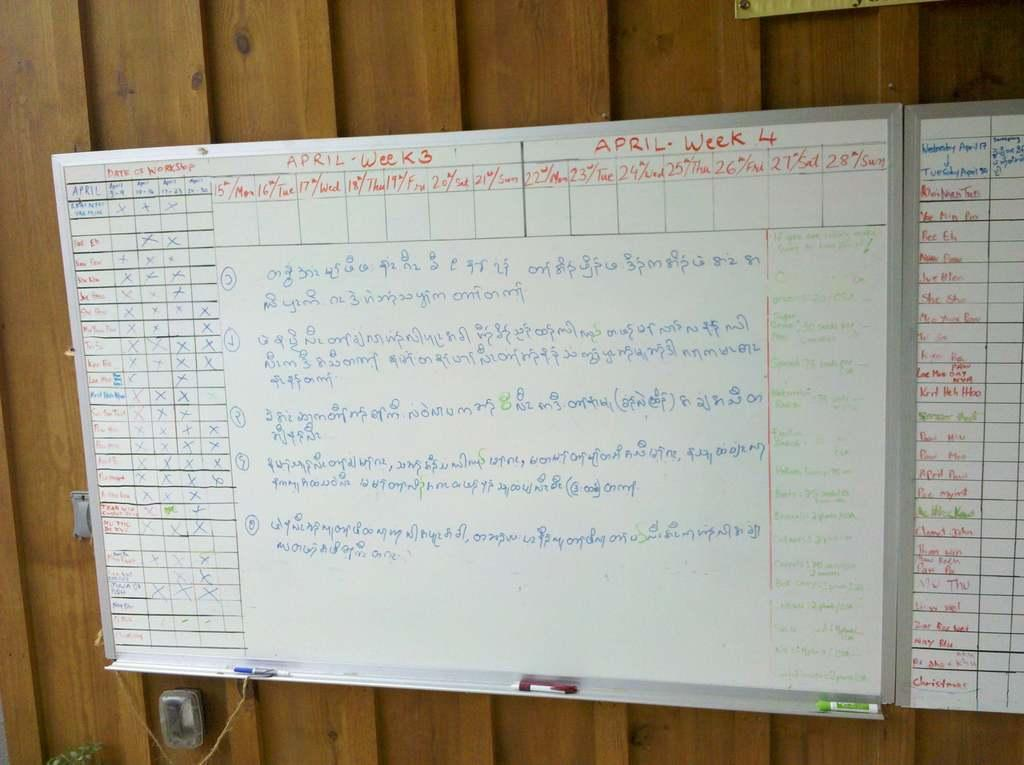<image>
Provide a brief description of the given image. A whiteboard with information for April Week 3 & April Week 4 showing when people are taking a workshop 